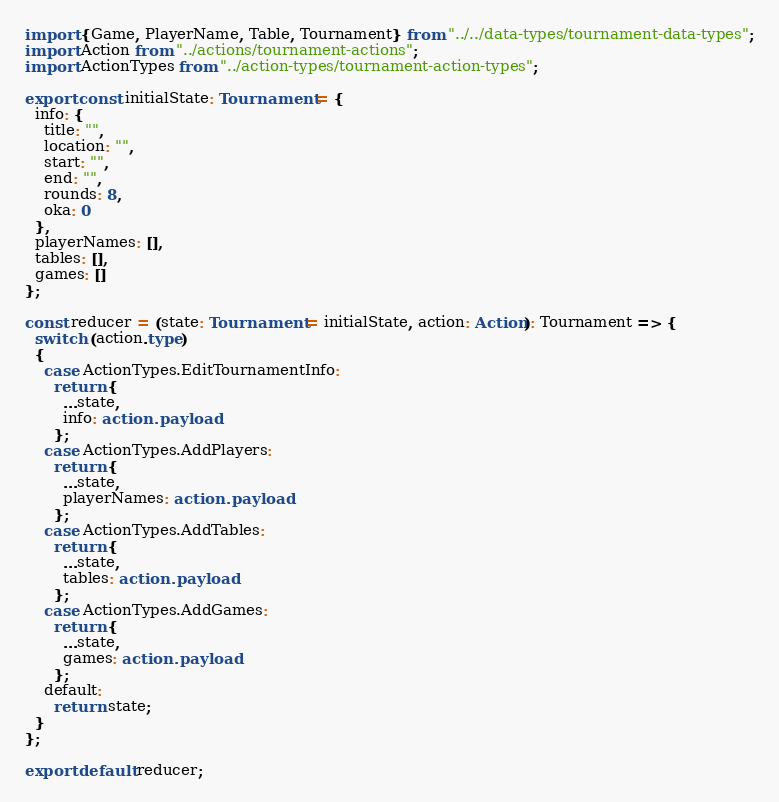Convert code to text. <code><loc_0><loc_0><loc_500><loc_500><_TypeScript_>import {Game, PlayerName, Table, Tournament} from "../../data-types/tournament-data-types";
import Action from "../actions/tournament-actions";
import ActionTypes from "../action-types/tournament-action-types";

export const initialState: Tournament = {
  info: {
    title: "",
    location: "",
    start: "",
    end: "",
    rounds: 8,
    oka: 0
  },
  playerNames: [],
  tables: [],
  games: []
};

const reducer = (state: Tournament = initialState, action: Action): Tournament => {
  switch (action.type)
  {
    case ActionTypes.EditTournamentInfo:
      return {
        ...state,
        info: action.payload
      };
    case ActionTypes.AddPlayers:
      return {
        ...state,
        playerNames: action.payload
      };
    case ActionTypes.AddTables:
      return {
        ...state,
        tables: action.payload
      };
    case ActionTypes.AddGames:
      return {
        ...state,
        games: action.payload
      };
    default:
      return state;
  }
};

export default reducer;</code> 